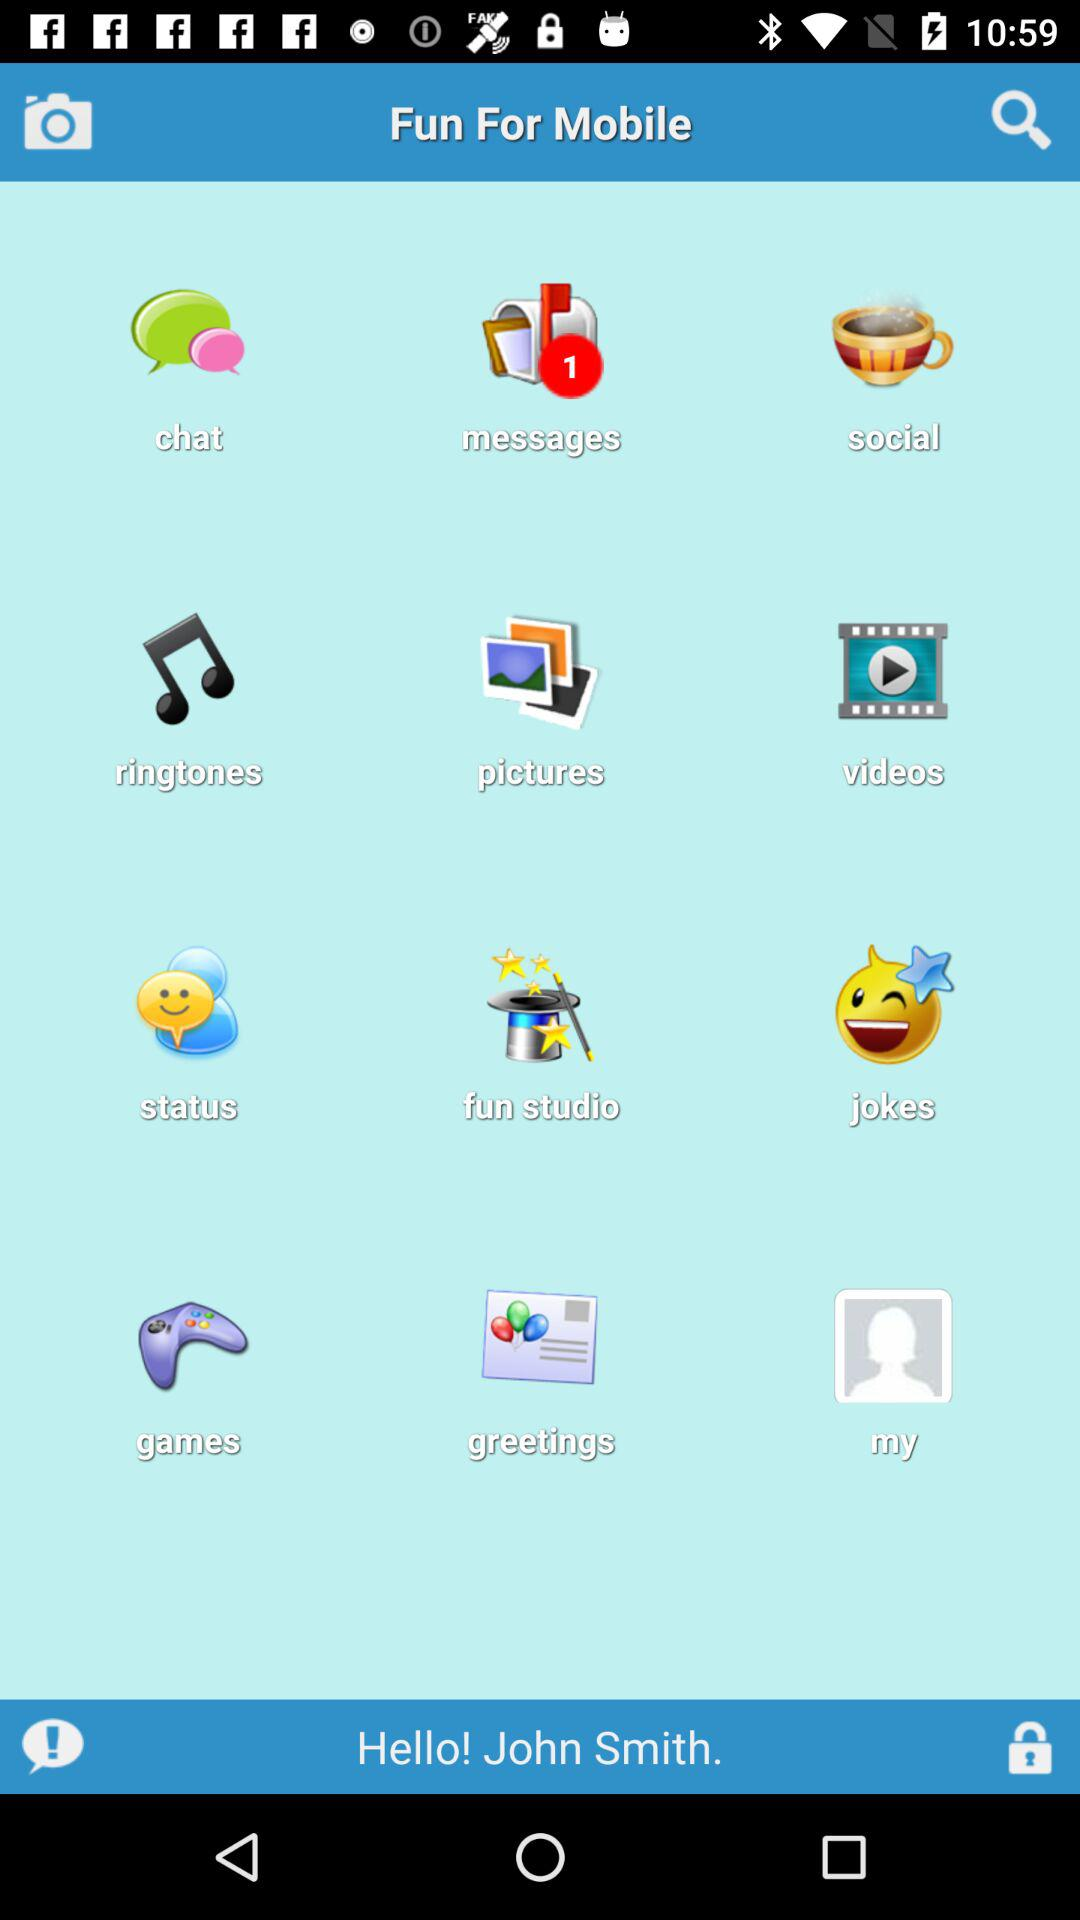What is the user name? The user name is John Smith. 